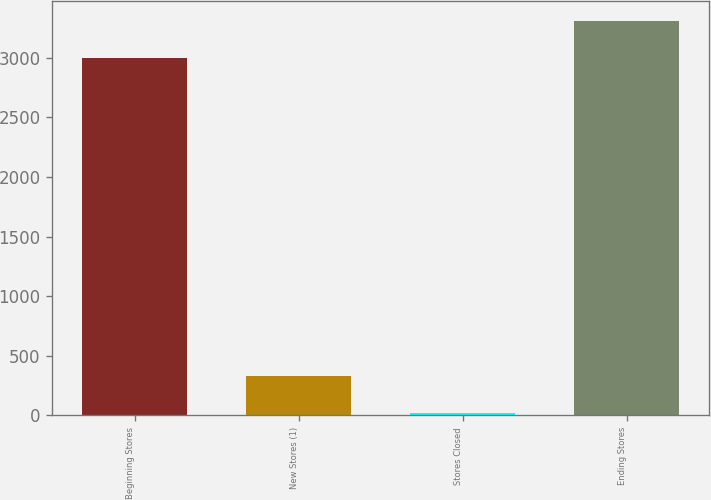<chart> <loc_0><loc_0><loc_500><loc_500><bar_chart><fcel>Beginning Stores<fcel>New Stores (1)<fcel>Stores Closed<fcel>Ending Stores<nl><fcel>2995<fcel>330.6<fcel>17<fcel>3308.6<nl></chart> 